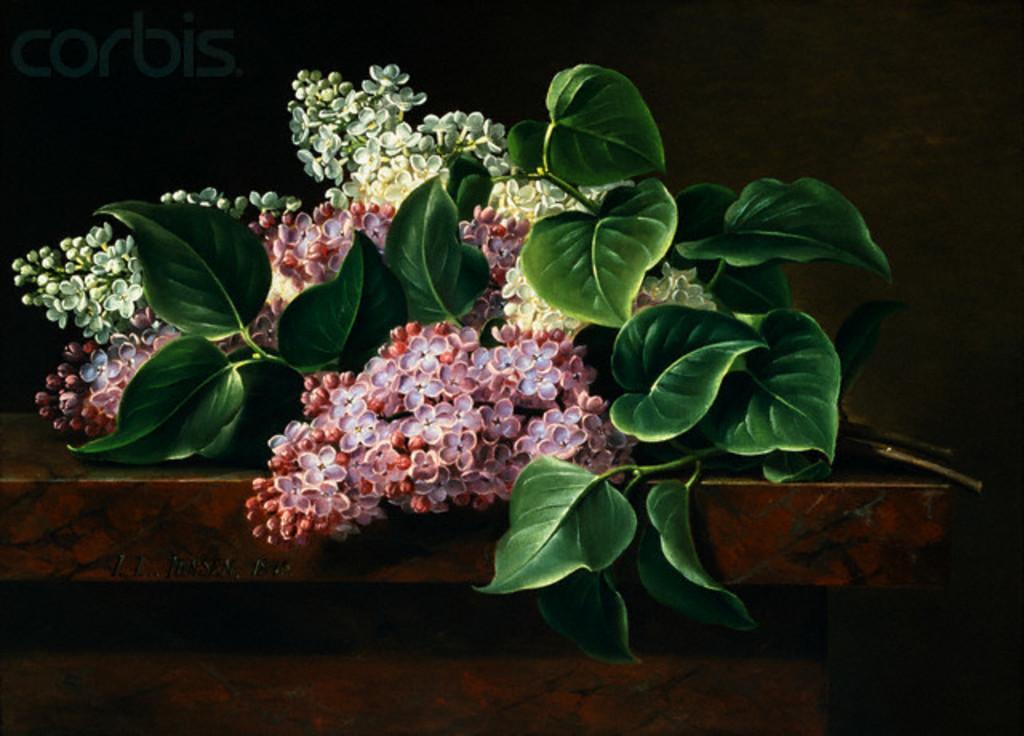Describe this image in one or two sentences. In the foreground of this image, there are an artificial flowers and leaves are placed on a table. In the background, there is a wall. 